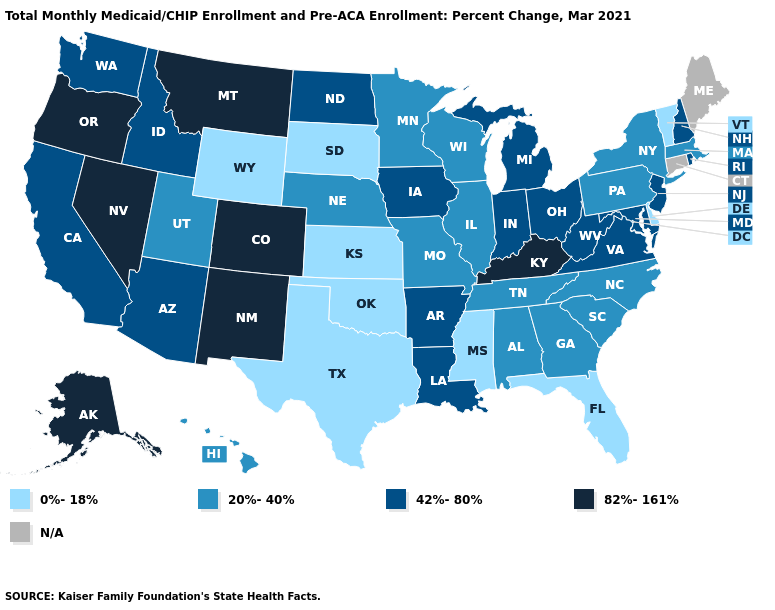What is the lowest value in the Northeast?
Short answer required. 0%-18%. Name the states that have a value in the range 42%-80%?
Short answer required. Arizona, Arkansas, California, Idaho, Indiana, Iowa, Louisiana, Maryland, Michigan, New Hampshire, New Jersey, North Dakota, Ohio, Rhode Island, Virginia, Washington, West Virginia. Among the states that border Texas , does Louisiana have the highest value?
Keep it brief. No. Name the states that have a value in the range 82%-161%?
Concise answer only. Alaska, Colorado, Kentucky, Montana, Nevada, New Mexico, Oregon. What is the highest value in states that border Washington?
Quick response, please. 82%-161%. Name the states that have a value in the range 82%-161%?
Keep it brief. Alaska, Colorado, Kentucky, Montana, Nevada, New Mexico, Oregon. Name the states that have a value in the range N/A?
Keep it brief. Connecticut, Maine. Name the states that have a value in the range 82%-161%?
Quick response, please. Alaska, Colorado, Kentucky, Montana, Nevada, New Mexico, Oregon. Does the first symbol in the legend represent the smallest category?
Keep it brief. Yes. Does the first symbol in the legend represent the smallest category?
Be succinct. Yes. What is the value of New York?
Keep it brief. 20%-40%. Name the states that have a value in the range 82%-161%?
Keep it brief. Alaska, Colorado, Kentucky, Montana, Nevada, New Mexico, Oregon. Name the states that have a value in the range 82%-161%?
Give a very brief answer. Alaska, Colorado, Kentucky, Montana, Nevada, New Mexico, Oregon. Which states have the lowest value in the South?
Concise answer only. Delaware, Florida, Mississippi, Oklahoma, Texas. How many symbols are there in the legend?
Keep it brief. 5. 